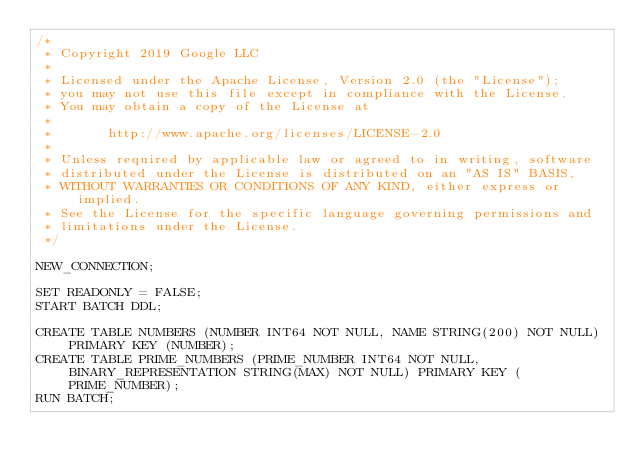<code> <loc_0><loc_0><loc_500><loc_500><_SQL_>/*
 * Copyright 2019 Google LLC
 *
 * Licensed under the Apache License, Version 2.0 (the "License");
 * you may not use this file except in compliance with the License.
 * You may obtain a copy of the License at
 *
 *       http://www.apache.org/licenses/LICENSE-2.0
 *
 * Unless required by applicable law or agreed to in writing, software
 * distributed under the License is distributed on an "AS IS" BASIS,
 * WITHOUT WARRANTIES OR CONDITIONS OF ANY KIND, either express or implied.
 * See the License for the specific language governing permissions and
 * limitations under the License.
 */

NEW_CONNECTION;

SET READONLY = FALSE;
START BATCH DDL;

CREATE TABLE NUMBERS (NUMBER INT64 NOT NULL, NAME STRING(200) NOT NULL) PRIMARY KEY (NUMBER);
CREATE TABLE PRIME_NUMBERS (PRIME_NUMBER INT64 NOT NULL, BINARY_REPRESENTATION STRING(MAX) NOT NULL) PRIMARY KEY (PRIME_NUMBER);
RUN BATCH;
</code> 